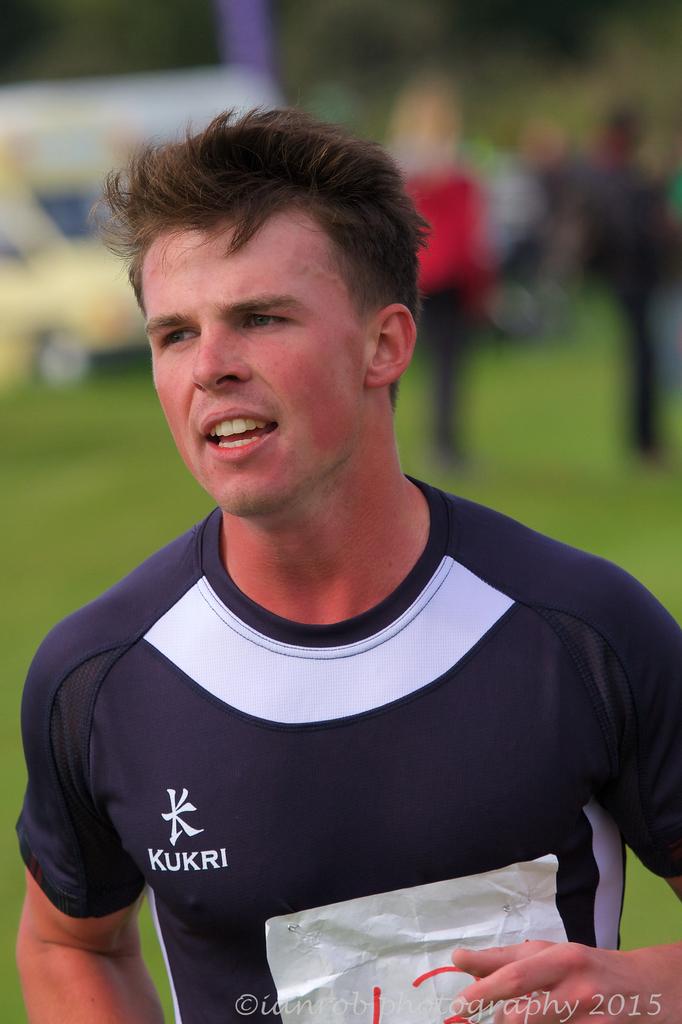What year was this made?
Provide a succinct answer. 2015. 